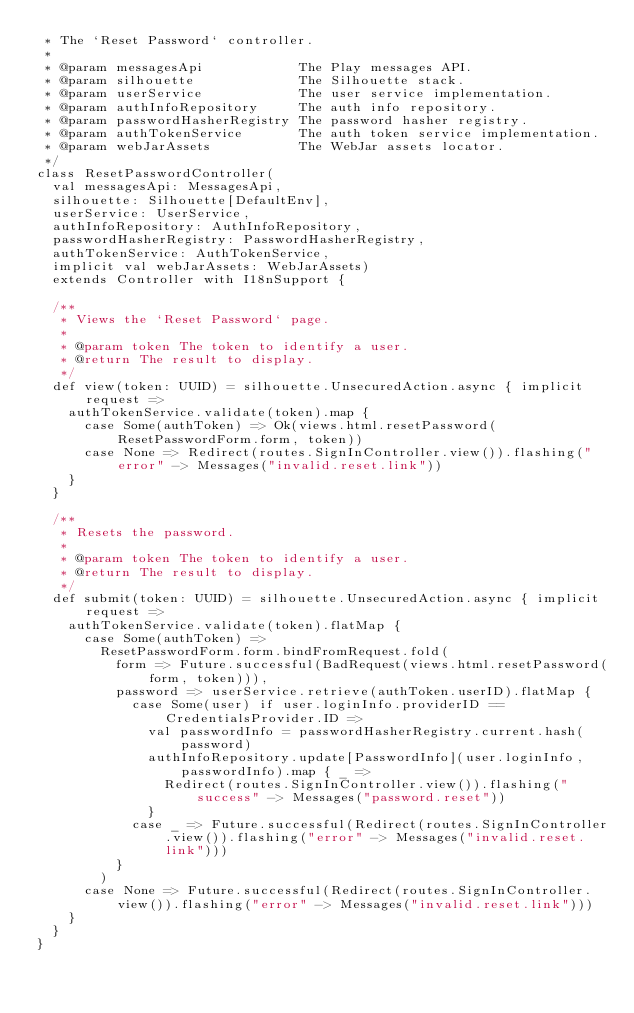Convert code to text. <code><loc_0><loc_0><loc_500><loc_500><_Scala_> * The `Reset Password` controller.
 *
 * @param messagesApi            The Play messages API.
 * @param silhouette             The Silhouette stack.
 * @param userService            The user service implementation.
 * @param authInfoRepository     The auth info repository.
 * @param passwordHasherRegistry The password hasher registry.
 * @param authTokenService       The auth token service implementation.
 * @param webJarAssets           The WebJar assets locator.
 */
class ResetPasswordController(
  val messagesApi: MessagesApi,
  silhouette: Silhouette[DefaultEnv],
  userService: UserService,
  authInfoRepository: AuthInfoRepository,
  passwordHasherRegistry: PasswordHasherRegistry,
  authTokenService: AuthTokenService,
  implicit val webJarAssets: WebJarAssets)
  extends Controller with I18nSupport {

  /**
   * Views the `Reset Password` page.
   *
   * @param token The token to identify a user.
   * @return The result to display.
   */
  def view(token: UUID) = silhouette.UnsecuredAction.async { implicit request =>
    authTokenService.validate(token).map {
      case Some(authToken) => Ok(views.html.resetPassword(ResetPasswordForm.form, token))
      case None => Redirect(routes.SignInController.view()).flashing("error" -> Messages("invalid.reset.link"))
    }
  }

  /**
   * Resets the password.
   *
   * @param token The token to identify a user.
   * @return The result to display.
   */
  def submit(token: UUID) = silhouette.UnsecuredAction.async { implicit request =>
    authTokenService.validate(token).flatMap {
      case Some(authToken) =>
        ResetPasswordForm.form.bindFromRequest.fold(
          form => Future.successful(BadRequest(views.html.resetPassword(form, token))),
          password => userService.retrieve(authToken.userID).flatMap {
            case Some(user) if user.loginInfo.providerID == CredentialsProvider.ID =>
              val passwordInfo = passwordHasherRegistry.current.hash(password)
              authInfoRepository.update[PasswordInfo](user.loginInfo, passwordInfo).map { _ =>
                Redirect(routes.SignInController.view()).flashing("success" -> Messages("password.reset"))
              }
            case _ => Future.successful(Redirect(routes.SignInController.view()).flashing("error" -> Messages("invalid.reset.link")))
          }
        )
      case None => Future.successful(Redirect(routes.SignInController.view()).flashing("error" -> Messages("invalid.reset.link")))
    }
  }
}
</code> 